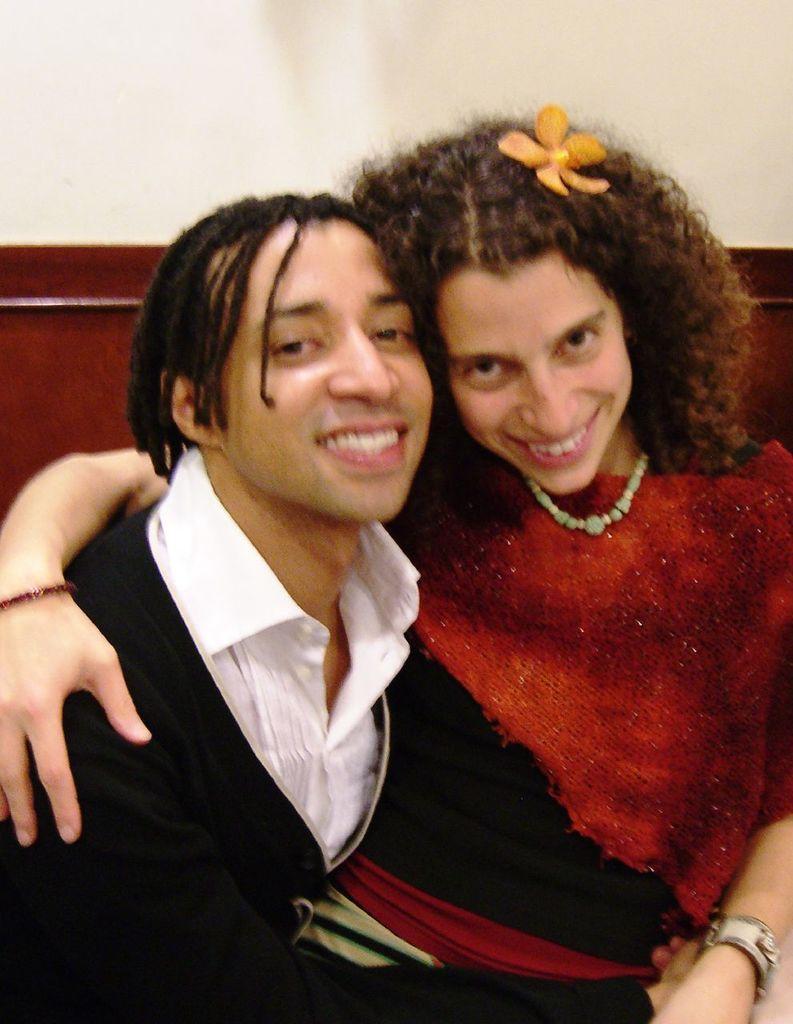How would you summarize this image in a sentence or two? In this image we can see two people sitting and there is a wall in the background and a wooden on object which looks like a board. 